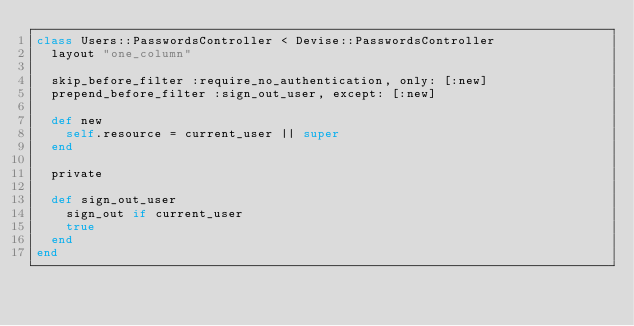<code> <loc_0><loc_0><loc_500><loc_500><_Ruby_>class Users::PasswordsController < Devise::PasswordsController
  layout "one_column"

  skip_before_filter :require_no_authentication, only: [:new]
  prepend_before_filter :sign_out_user, except: [:new]

  def new
    self.resource = current_user || super
  end

  private

  def sign_out_user
    sign_out if current_user
    true
  end
end
</code> 